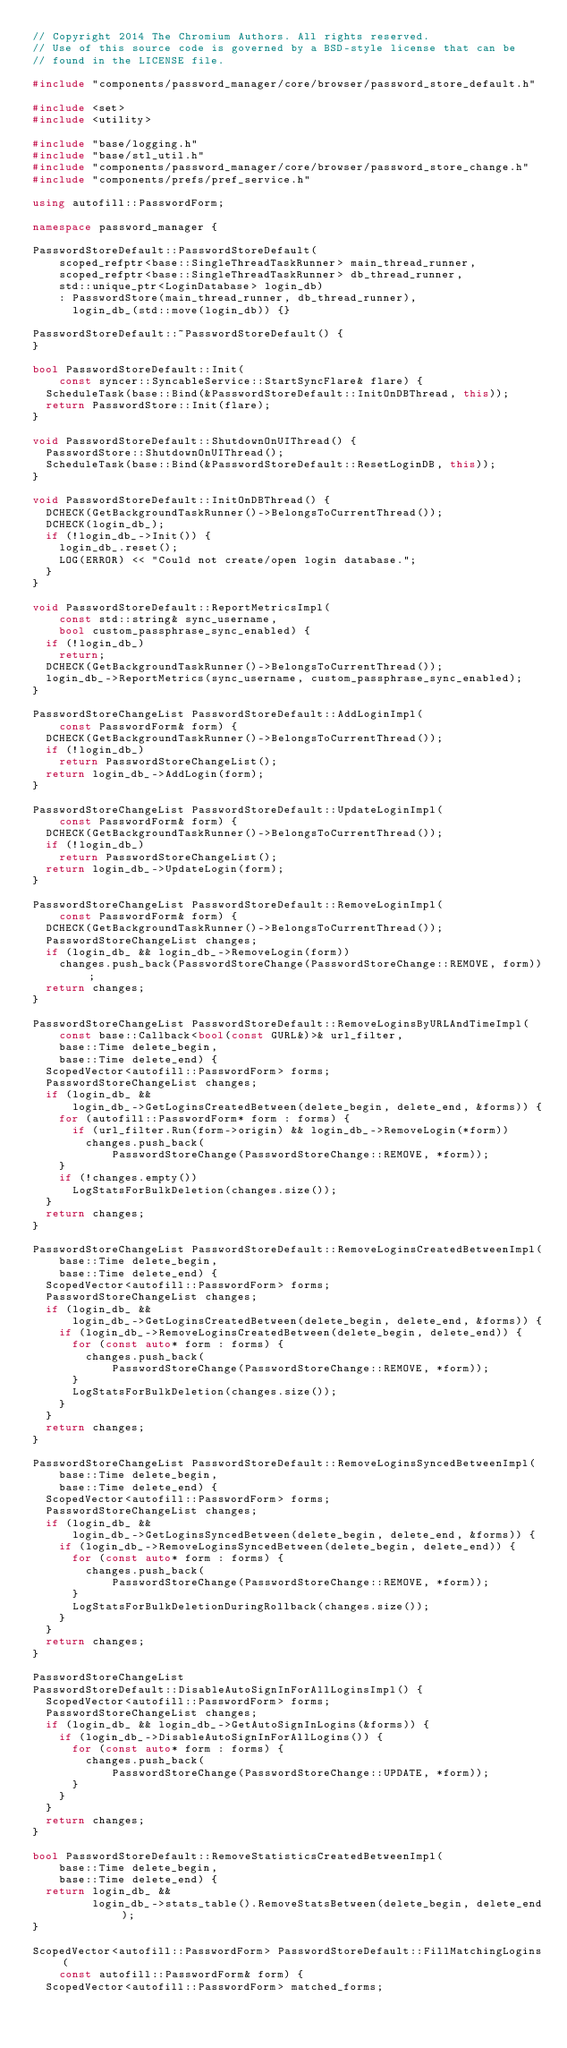Convert code to text. <code><loc_0><loc_0><loc_500><loc_500><_C++_>// Copyright 2014 The Chromium Authors. All rights reserved.
// Use of this source code is governed by a BSD-style license that can be
// found in the LICENSE file.

#include "components/password_manager/core/browser/password_store_default.h"

#include <set>
#include <utility>

#include "base/logging.h"
#include "base/stl_util.h"
#include "components/password_manager/core/browser/password_store_change.h"
#include "components/prefs/pref_service.h"

using autofill::PasswordForm;

namespace password_manager {

PasswordStoreDefault::PasswordStoreDefault(
    scoped_refptr<base::SingleThreadTaskRunner> main_thread_runner,
    scoped_refptr<base::SingleThreadTaskRunner> db_thread_runner,
    std::unique_ptr<LoginDatabase> login_db)
    : PasswordStore(main_thread_runner, db_thread_runner),
      login_db_(std::move(login_db)) {}

PasswordStoreDefault::~PasswordStoreDefault() {
}

bool PasswordStoreDefault::Init(
    const syncer::SyncableService::StartSyncFlare& flare) {
  ScheduleTask(base::Bind(&PasswordStoreDefault::InitOnDBThread, this));
  return PasswordStore::Init(flare);
}

void PasswordStoreDefault::ShutdownOnUIThread() {
  PasswordStore::ShutdownOnUIThread();
  ScheduleTask(base::Bind(&PasswordStoreDefault::ResetLoginDB, this));
}

void PasswordStoreDefault::InitOnDBThread() {
  DCHECK(GetBackgroundTaskRunner()->BelongsToCurrentThread());
  DCHECK(login_db_);
  if (!login_db_->Init()) {
    login_db_.reset();
    LOG(ERROR) << "Could not create/open login database.";
  }
}

void PasswordStoreDefault::ReportMetricsImpl(
    const std::string& sync_username,
    bool custom_passphrase_sync_enabled) {
  if (!login_db_)
    return;
  DCHECK(GetBackgroundTaskRunner()->BelongsToCurrentThread());
  login_db_->ReportMetrics(sync_username, custom_passphrase_sync_enabled);
}

PasswordStoreChangeList PasswordStoreDefault::AddLoginImpl(
    const PasswordForm& form) {
  DCHECK(GetBackgroundTaskRunner()->BelongsToCurrentThread());
  if (!login_db_)
    return PasswordStoreChangeList();
  return login_db_->AddLogin(form);
}

PasswordStoreChangeList PasswordStoreDefault::UpdateLoginImpl(
    const PasswordForm& form) {
  DCHECK(GetBackgroundTaskRunner()->BelongsToCurrentThread());
  if (!login_db_)
    return PasswordStoreChangeList();
  return login_db_->UpdateLogin(form);
}

PasswordStoreChangeList PasswordStoreDefault::RemoveLoginImpl(
    const PasswordForm& form) {
  DCHECK(GetBackgroundTaskRunner()->BelongsToCurrentThread());
  PasswordStoreChangeList changes;
  if (login_db_ && login_db_->RemoveLogin(form))
    changes.push_back(PasswordStoreChange(PasswordStoreChange::REMOVE, form));
  return changes;
}

PasswordStoreChangeList PasswordStoreDefault::RemoveLoginsByURLAndTimeImpl(
    const base::Callback<bool(const GURL&)>& url_filter,
    base::Time delete_begin,
    base::Time delete_end) {
  ScopedVector<autofill::PasswordForm> forms;
  PasswordStoreChangeList changes;
  if (login_db_ &&
      login_db_->GetLoginsCreatedBetween(delete_begin, delete_end, &forms)) {
    for (autofill::PasswordForm* form : forms) {
      if (url_filter.Run(form->origin) && login_db_->RemoveLogin(*form))
        changes.push_back(
            PasswordStoreChange(PasswordStoreChange::REMOVE, *form));
    }
    if (!changes.empty())
      LogStatsForBulkDeletion(changes.size());
  }
  return changes;
}

PasswordStoreChangeList PasswordStoreDefault::RemoveLoginsCreatedBetweenImpl(
    base::Time delete_begin,
    base::Time delete_end) {
  ScopedVector<autofill::PasswordForm> forms;
  PasswordStoreChangeList changes;
  if (login_db_ &&
      login_db_->GetLoginsCreatedBetween(delete_begin, delete_end, &forms)) {
    if (login_db_->RemoveLoginsCreatedBetween(delete_begin, delete_end)) {
      for (const auto* form : forms) {
        changes.push_back(
            PasswordStoreChange(PasswordStoreChange::REMOVE, *form));
      }
      LogStatsForBulkDeletion(changes.size());
    }
  }
  return changes;
}

PasswordStoreChangeList PasswordStoreDefault::RemoveLoginsSyncedBetweenImpl(
    base::Time delete_begin,
    base::Time delete_end) {
  ScopedVector<autofill::PasswordForm> forms;
  PasswordStoreChangeList changes;
  if (login_db_ &&
      login_db_->GetLoginsSyncedBetween(delete_begin, delete_end, &forms)) {
    if (login_db_->RemoveLoginsSyncedBetween(delete_begin, delete_end)) {
      for (const auto* form : forms) {
        changes.push_back(
            PasswordStoreChange(PasswordStoreChange::REMOVE, *form));
      }
      LogStatsForBulkDeletionDuringRollback(changes.size());
    }
  }
  return changes;
}

PasswordStoreChangeList
PasswordStoreDefault::DisableAutoSignInForAllLoginsImpl() {
  ScopedVector<autofill::PasswordForm> forms;
  PasswordStoreChangeList changes;
  if (login_db_ && login_db_->GetAutoSignInLogins(&forms)) {
    if (login_db_->DisableAutoSignInForAllLogins()) {
      for (const auto* form : forms) {
        changes.push_back(
            PasswordStoreChange(PasswordStoreChange::UPDATE, *form));
      }
    }
  }
  return changes;
}

bool PasswordStoreDefault::RemoveStatisticsCreatedBetweenImpl(
    base::Time delete_begin,
    base::Time delete_end) {
  return login_db_ &&
         login_db_->stats_table().RemoveStatsBetween(delete_begin, delete_end);
}

ScopedVector<autofill::PasswordForm> PasswordStoreDefault::FillMatchingLogins(
    const autofill::PasswordForm& form) {
  ScopedVector<autofill::PasswordForm> matched_forms;</code> 